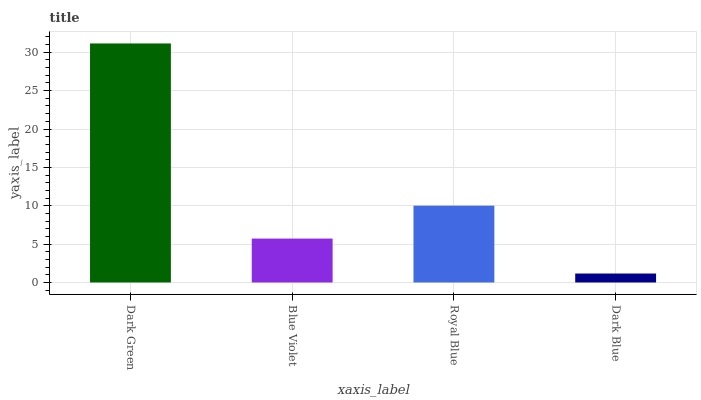Is Dark Blue the minimum?
Answer yes or no. Yes. Is Dark Green the maximum?
Answer yes or no. Yes. Is Blue Violet the minimum?
Answer yes or no. No. Is Blue Violet the maximum?
Answer yes or no. No. Is Dark Green greater than Blue Violet?
Answer yes or no. Yes. Is Blue Violet less than Dark Green?
Answer yes or no. Yes. Is Blue Violet greater than Dark Green?
Answer yes or no. No. Is Dark Green less than Blue Violet?
Answer yes or no. No. Is Royal Blue the high median?
Answer yes or no. Yes. Is Blue Violet the low median?
Answer yes or no. Yes. Is Dark Green the high median?
Answer yes or no. No. Is Dark Green the low median?
Answer yes or no. No. 